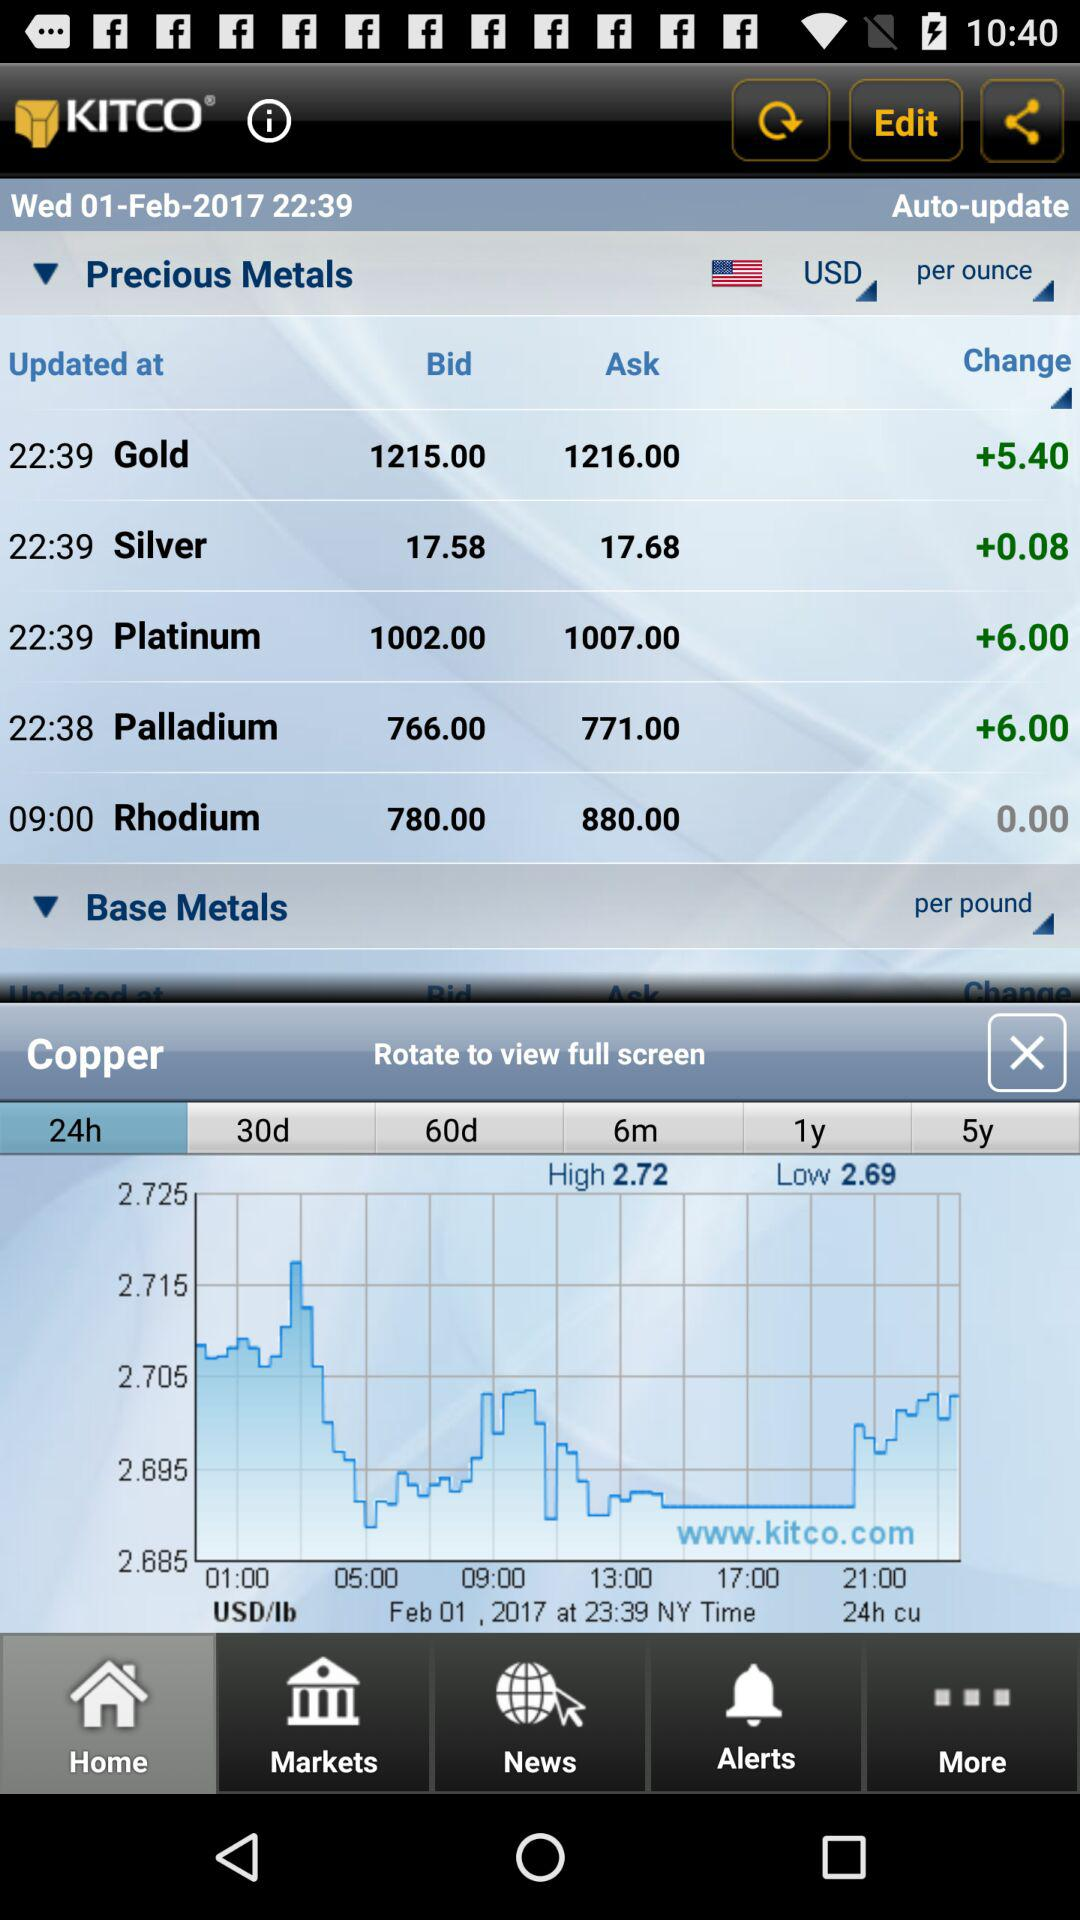What is the date? The date is Wednesday, February 01, 2017. 